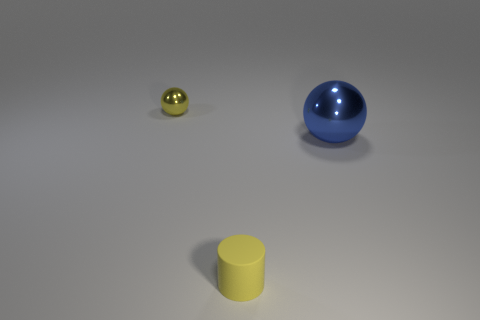Add 3 big metallic balls. How many objects exist? 6 Subtract all spheres. How many objects are left? 1 Add 1 purple matte balls. How many purple matte balls exist? 1 Subtract 1 blue spheres. How many objects are left? 2 Subtract all tiny gray cylinders. Subtract all blue metallic balls. How many objects are left? 2 Add 2 large blue metal balls. How many large blue metal balls are left? 3 